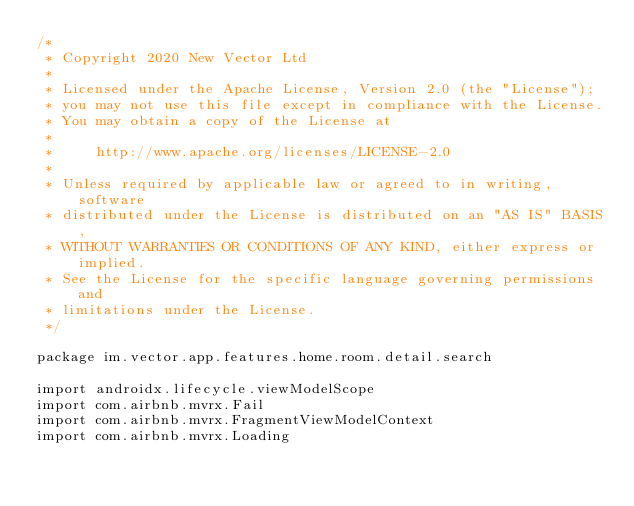Convert code to text. <code><loc_0><loc_0><loc_500><loc_500><_Kotlin_>/*
 * Copyright 2020 New Vector Ltd
 *
 * Licensed under the Apache License, Version 2.0 (the "License");
 * you may not use this file except in compliance with the License.
 * You may obtain a copy of the License at
 *
 *     http://www.apache.org/licenses/LICENSE-2.0
 *
 * Unless required by applicable law or agreed to in writing, software
 * distributed under the License is distributed on an "AS IS" BASIS,
 * WITHOUT WARRANTIES OR CONDITIONS OF ANY KIND, either express or implied.
 * See the License for the specific language governing permissions and
 * limitations under the License.
 */

package im.vector.app.features.home.room.detail.search

import androidx.lifecycle.viewModelScope
import com.airbnb.mvrx.Fail
import com.airbnb.mvrx.FragmentViewModelContext
import com.airbnb.mvrx.Loading</code> 